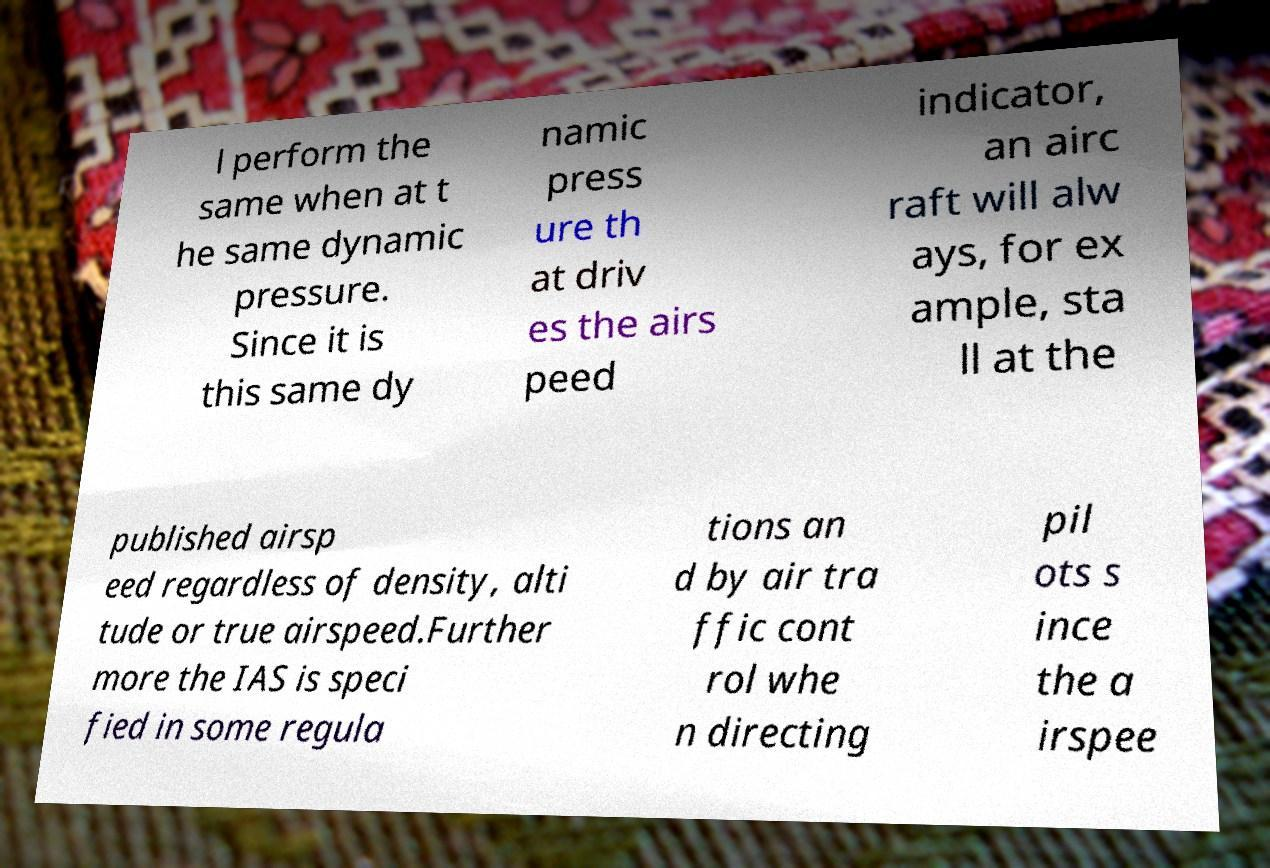I need the written content from this picture converted into text. Can you do that? l perform the same when at t he same dynamic pressure. Since it is this same dy namic press ure th at driv es the airs peed indicator, an airc raft will alw ays, for ex ample, sta ll at the published airsp eed regardless of density, alti tude or true airspeed.Further more the IAS is speci fied in some regula tions an d by air tra ffic cont rol whe n directing pil ots s ince the a irspee 